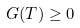<formula> <loc_0><loc_0><loc_500><loc_500>G ( T ) \geq 0</formula> 